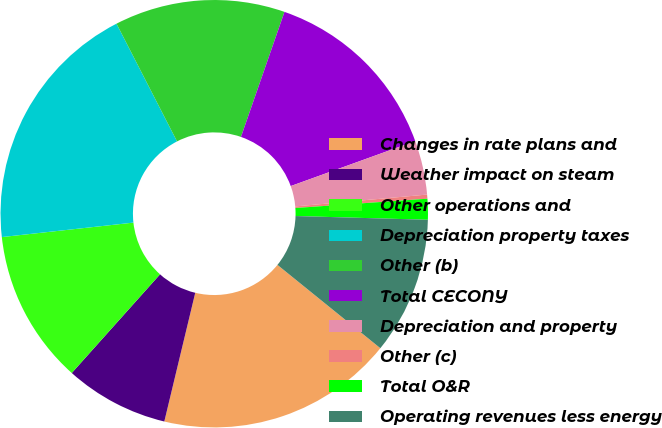Convert chart. <chart><loc_0><loc_0><loc_500><loc_500><pie_chart><fcel>Changes in rate plans and<fcel>Weather impact on steam<fcel>Other operations and<fcel>Depreciation property taxes<fcel>Other (b)<fcel>Total CECONY<fcel>Depreciation and property<fcel>Other (c)<fcel>Total O&R<fcel>Operating revenues less energy<nl><fcel>17.92%<fcel>7.86%<fcel>11.64%<fcel>19.18%<fcel>12.89%<fcel>14.15%<fcel>4.09%<fcel>0.31%<fcel>1.57%<fcel>10.38%<nl></chart> 